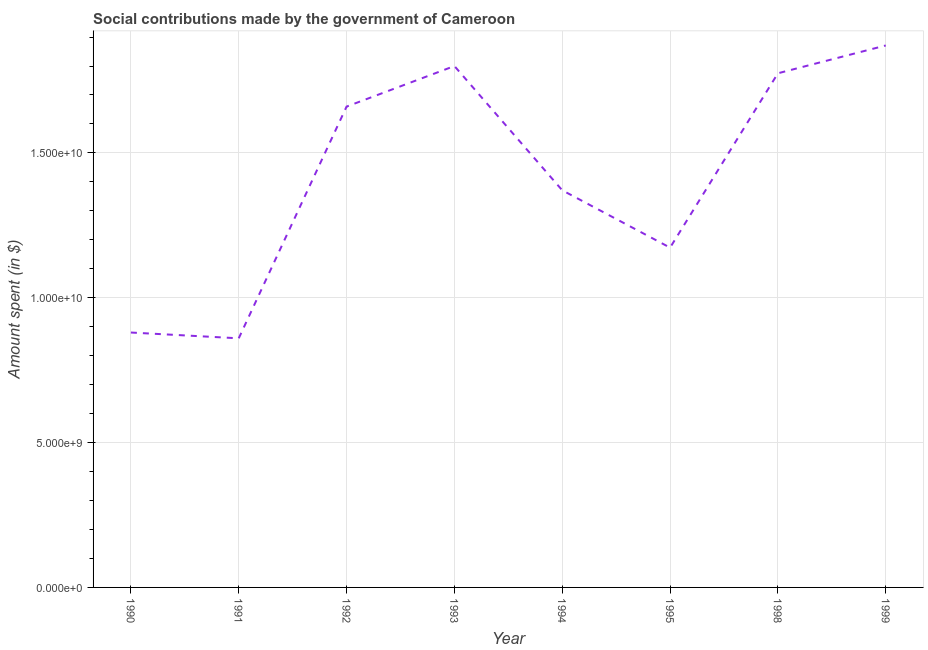What is the amount spent in making social contributions in 1995?
Give a very brief answer. 1.17e+1. Across all years, what is the maximum amount spent in making social contributions?
Your response must be concise. 1.87e+1. Across all years, what is the minimum amount spent in making social contributions?
Provide a short and direct response. 8.60e+09. In which year was the amount spent in making social contributions minimum?
Make the answer very short. 1991. What is the sum of the amount spent in making social contributions?
Provide a succinct answer. 1.14e+11. What is the difference between the amount spent in making social contributions in 1994 and 1999?
Provide a short and direct response. -5.00e+09. What is the average amount spent in making social contributions per year?
Your response must be concise. 1.42e+1. What is the median amount spent in making social contributions?
Your answer should be very brief. 1.52e+1. Do a majority of the years between 1999 and 1993 (inclusive) have amount spent in making social contributions greater than 16000000000 $?
Your response must be concise. Yes. What is the ratio of the amount spent in making social contributions in 1990 to that in 1994?
Provide a succinct answer. 0.64. Is the amount spent in making social contributions in 1993 less than that in 1994?
Give a very brief answer. No. What is the difference between the highest and the second highest amount spent in making social contributions?
Provide a succinct answer. 7.10e+08. What is the difference between the highest and the lowest amount spent in making social contributions?
Make the answer very short. 1.01e+1. How many lines are there?
Keep it short and to the point. 1. How many years are there in the graph?
Provide a succinct answer. 8. Does the graph contain any zero values?
Make the answer very short. No. What is the title of the graph?
Your answer should be very brief. Social contributions made by the government of Cameroon. What is the label or title of the Y-axis?
Offer a very short reply. Amount spent (in $). What is the Amount spent (in $) in 1990?
Your answer should be very brief. 8.80e+09. What is the Amount spent (in $) in 1991?
Make the answer very short. 8.60e+09. What is the Amount spent (in $) of 1992?
Your answer should be very brief. 1.66e+1. What is the Amount spent (in $) of 1993?
Provide a short and direct response. 1.80e+1. What is the Amount spent (in $) of 1994?
Provide a short and direct response. 1.37e+1. What is the Amount spent (in $) in 1995?
Ensure brevity in your answer.  1.17e+1. What is the Amount spent (in $) of 1998?
Give a very brief answer. 1.78e+1. What is the Amount spent (in $) of 1999?
Your answer should be compact. 1.87e+1. What is the difference between the Amount spent (in $) in 1990 and 1992?
Give a very brief answer. -7.80e+09. What is the difference between the Amount spent (in $) in 1990 and 1993?
Your answer should be very brief. -9.20e+09. What is the difference between the Amount spent (in $) in 1990 and 1994?
Your answer should be very brief. -4.91e+09. What is the difference between the Amount spent (in $) in 1990 and 1995?
Provide a succinct answer. -2.93e+09. What is the difference between the Amount spent (in $) in 1990 and 1998?
Your answer should be compact. -8.95e+09. What is the difference between the Amount spent (in $) in 1990 and 1999?
Offer a terse response. -9.91e+09. What is the difference between the Amount spent (in $) in 1991 and 1992?
Your answer should be very brief. -8.00e+09. What is the difference between the Amount spent (in $) in 1991 and 1993?
Make the answer very short. -9.40e+09. What is the difference between the Amount spent (in $) in 1991 and 1994?
Offer a very short reply. -5.11e+09. What is the difference between the Amount spent (in $) in 1991 and 1995?
Your answer should be compact. -3.13e+09. What is the difference between the Amount spent (in $) in 1991 and 1998?
Your answer should be very brief. -9.15e+09. What is the difference between the Amount spent (in $) in 1991 and 1999?
Provide a short and direct response. -1.01e+1. What is the difference between the Amount spent (in $) in 1992 and 1993?
Offer a very short reply. -1.40e+09. What is the difference between the Amount spent (in $) in 1992 and 1994?
Keep it short and to the point. 2.89e+09. What is the difference between the Amount spent (in $) in 1992 and 1995?
Make the answer very short. 4.87e+09. What is the difference between the Amount spent (in $) in 1992 and 1998?
Provide a short and direct response. -1.15e+09. What is the difference between the Amount spent (in $) in 1992 and 1999?
Provide a succinct answer. -2.11e+09. What is the difference between the Amount spent (in $) in 1993 and 1994?
Provide a succinct answer. 4.29e+09. What is the difference between the Amount spent (in $) in 1993 and 1995?
Provide a succinct answer. 6.27e+09. What is the difference between the Amount spent (in $) in 1993 and 1998?
Give a very brief answer. 2.50e+08. What is the difference between the Amount spent (in $) in 1993 and 1999?
Provide a succinct answer. -7.10e+08. What is the difference between the Amount spent (in $) in 1994 and 1995?
Keep it short and to the point. 1.98e+09. What is the difference between the Amount spent (in $) in 1994 and 1998?
Your response must be concise. -4.04e+09. What is the difference between the Amount spent (in $) in 1994 and 1999?
Give a very brief answer. -5.00e+09. What is the difference between the Amount spent (in $) in 1995 and 1998?
Keep it short and to the point. -6.02e+09. What is the difference between the Amount spent (in $) in 1995 and 1999?
Your response must be concise. -6.98e+09. What is the difference between the Amount spent (in $) in 1998 and 1999?
Offer a very short reply. -9.60e+08. What is the ratio of the Amount spent (in $) in 1990 to that in 1992?
Keep it short and to the point. 0.53. What is the ratio of the Amount spent (in $) in 1990 to that in 1993?
Provide a succinct answer. 0.49. What is the ratio of the Amount spent (in $) in 1990 to that in 1994?
Provide a short and direct response. 0.64. What is the ratio of the Amount spent (in $) in 1990 to that in 1995?
Make the answer very short. 0.75. What is the ratio of the Amount spent (in $) in 1990 to that in 1998?
Your answer should be compact. 0.5. What is the ratio of the Amount spent (in $) in 1990 to that in 1999?
Give a very brief answer. 0.47. What is the ratio of the Amount spent (in $) in 1991 to that in 1992?
Ensure brevity in your answer.  0.52. What is the ratio of the Amount spent (in $) in 1991 to that in 1993?
Offer a very short reply. 0.48. What is the ratio of the Amount spent (in $) in 1991 to that in 1994?
Keep it short and to the point. 0.63. What is the ratio of the Amount spent (in $) in 1991 to that in 1995?
Keep it short and to the point. 0.73. What is the ratio of the Amount spent (in $) in 1991 to that in 1998?
Your response must be concise. 0.48. What is the ratio of the Amount spent (in $) in 1991 to that in 1999?
Provide a short and direct response. 0.46. What is the ratio of the Amount spent (in $) in 1992 to that in 1993?
Offer a very short reply. 0.92. What is the ratio of the Amount spent (in $) in 1992 to that in 1994?
Provide a short and direct response. 1.21. What is the ratio of the Amount spent (in $) in 1992 to that in 1995?
Make the answer very short. 1.42. What is the ratio of the Amount spent (in $) in 1992 to that in 1998?
Give a very brief answer. 0.94. What is the ratio of the Amount spent (in $) in 1992 to that in 1999?
Offer a terse response. 0.89. What is the ratio of the Amount spent (in $) in 1993 to that in 1994?
Provide a short and direct response. 1.31. What is the ratio of the Amount spent (in $) in 1993 to that in 1995?
Give a very brief answer. 1.53. What is the ratio of the Amount spent (in $) in 1994 to that in 1995?
Your response must be concise. 1.17. What is the ratio of the Amount spent (in $) in 1994 to that in 1998?
Give a very brief answer. 0.77. What is the ratio of the Amount spent (in $) in 1994 to that in 1999?
Give a very brief answer. 0.73. What is the ratio of the Amount spent (in $) in 1995 to that in 1998?
Offer a very short reply. 0.66. What is the ratio of the Amount spent (in $) in 1995 to that in 1999?
Offer a terse response. 0.63. What is the ratio of the Amount spent (in $) in 1998 to that in 1999?
Ensure brevity in your answer.  0.95. 